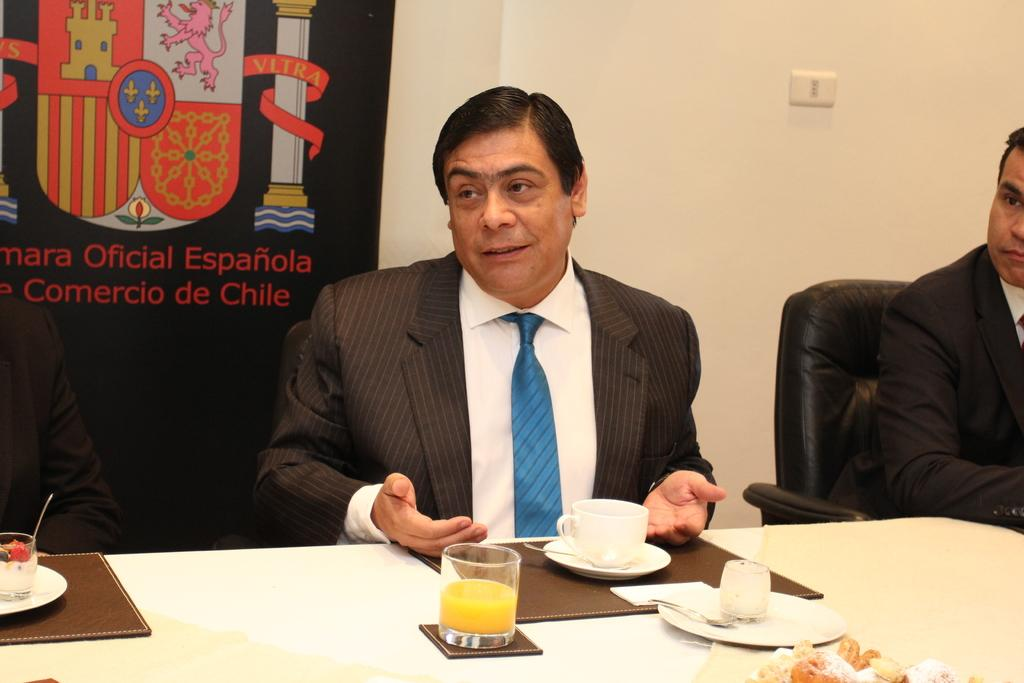What are the people in the image doing? The people in the image are sitting on chairs. What objects can be seen on the table in the image? There is a cup, a glass, and food on the table. What is attached to the wall in the background of the image? There is a banner attached to the wall in the background. How many chickens are present in the image? There are no chickens present in the image. What message does the banner in the image convey about hope? The image does not provide any information about the message on the banner, nor does it mention anything about hope. 